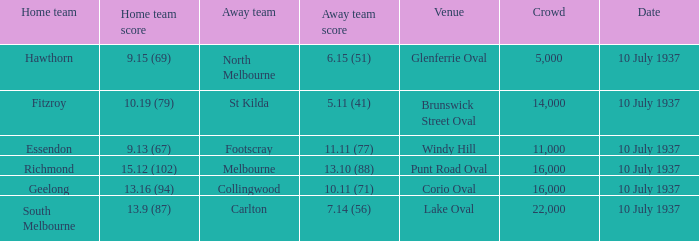What was the Venue of the North Melbourne Away Team? Glenferrie Oval. 